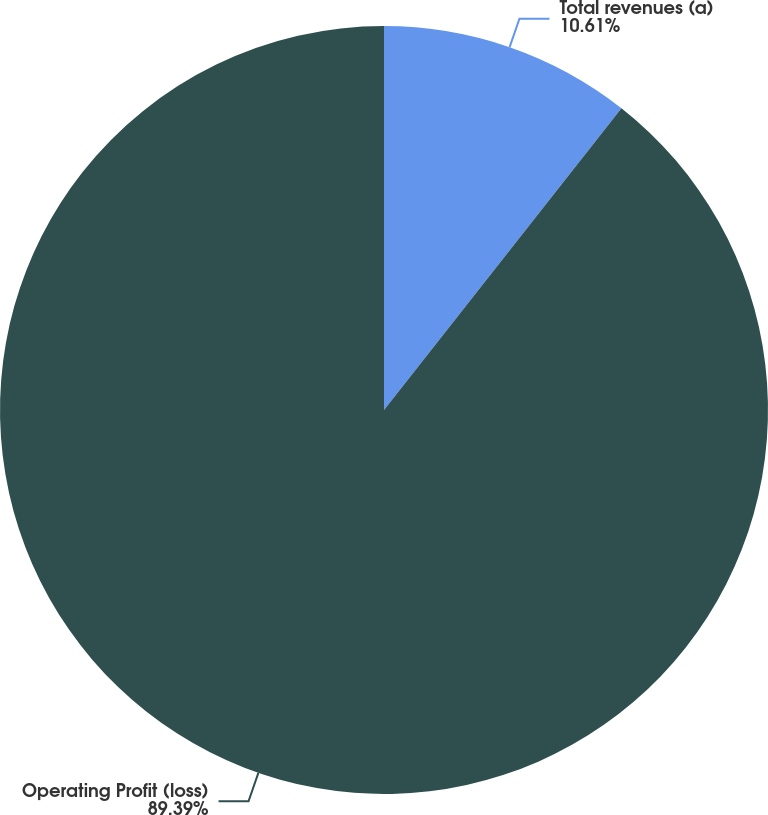Convert chart to OTSL. <chart><loc_0><loc_0><loc_500><loc_500><pie_chart><fcel>Total revenues (a)<fcel>Operating Profit (loss)<nl><fcel>10.61%<fcel>89.39%<nl></chart> 